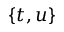<formula> <loc_0><loc_0><loc_500><loc_500>\{ t , u \}</formula> 